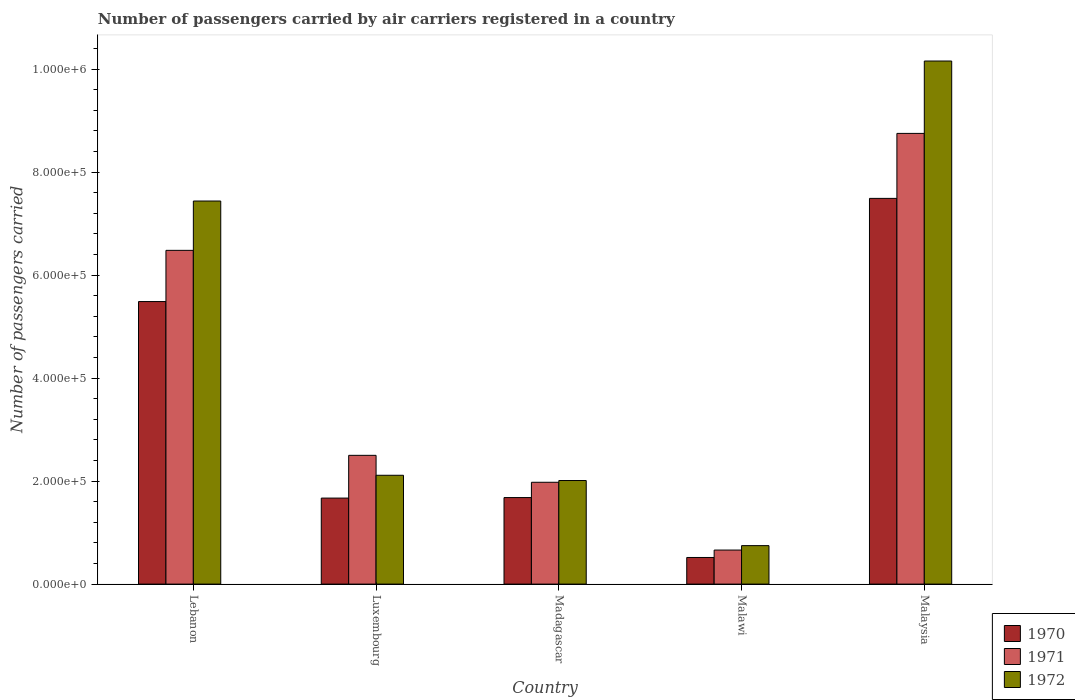How many different coloured bars are there?
Make the answer very short. 3. How many groups of bars are there?
Your answer should be very brief. 5. Are the number of bars per tick equal to the number of legend labels?
Your response must be concise. Yes. What is the label of the 3rd group of bars from the left?
Your answer should be compact. Madagascar. In how many cases, is the number of bars for a given country not equal to the number of legend labels?
Provide a short and direct response. 0. What is the number of passengers carried by air carriers in 1971 in Lebanon?
Your answer should be very brief. 6.48e+05. Across all countries, what is the maximum number of passengers carried by air carriers in 1970?
Provide a succinct answer. 7.49e+05. Across all countries, what is the minimum number of passengers carried by air carriers in 1972?
Your response must be concise. 7.47e+04. In which country was the number of passengers carried by air carriers in 1971 maximum?
Offer a very short reply. Malaysia. In which country was the number of passengers carried by air carriers in 1971 minimum?
Offer a terse response. Malawi. What is the total number of passengers carried by air carriers in 1970 in the graph?
Make the answer very short. 1.68e+06. What is the difference between the number of passengers carried by air carriers in 1970 in Luxembourg and that in Malawi?
Your answer should be very brief. 1.15e+05. What is the difference between the number of passengers carried by air carriers in 1972 in Luxembourg and the number of passengers carried by air carriers in 1971 in Lebanon?
Offer a terse response. -4.37e+05. What is the average number of passengers carried by air carriers in 1971 per country?
Your answer should be compact. 4.07e+05. What is the difference between the number of passengers carried by air carriers of/in 1970 and number of passengers carried by air carriers of/in 1972 in Lebanon?
Your response must be concise. -1.95e+05. In how many countries, is the number of passengers carried by air carriers in 1972 greater than 760000?
Offer a very short reply. 1. What is the ratio of the number of passengers carried by air carriers in 1971 in Luxembourg to that in Madagascar?
Offer a very short reply. 1.26. Is the number of passengers carried by air carriers in 1970 in Madagascar less than that in Malawi?
Provide a short and direct response. No. What is the difference between the highest and the second highest number of passengers carried by air carriers in 1972?
Make the answer very short. 2.72e+05. What is the difference between the highest and the lowest number of passengers carried by air carriers in 1970?
Your response must be concise. 6.97e+05. In how many countries, is the number of passengers carried by air carriers in 1972 greater than the average number of passengers carried by air carriers in 1972 taken over all countries?
Provide a short and direct response. 2. Is it the case that in every country, the sum of the number of passengers carried by air carriers in 1971 and number of passengers carried by air carriers in 1972 is greater than the number of passengers carried by air carriers in 1970?
Offer a very short reply. Yes. How many bars are there?
Your response must be concise. 15. How many countries are there in the graph?
Give a very brief answer. 5. What is the difference between two consecutive major ticks on the Y-axis?
Keep it short and to the point. 2.00e+05. Does the graph contain any zero values?
Give a very brief answer. No. Does the graph contain grids?
Offer a very short reply. No. Where does the legend appear in the graph?
Provide a succinct answer. Bottom right. How many legend labels are there?
Offer a very short reply. 3. What is the title of the graph?
Give a very brief answer. Number of passengers carried by air carriers registered in a country. What is the label or title of the Y-axis?
Ensure brevity in your answer.  Number of passengers carried. What is the Number of passengers carried in 1970 in Lebanon?
Ensure brevity in your answer.  5.49e+05. What is the Number of passengers carried of 1971 in Lebanon?
Your answer should be very brief. 6.48e+05. What is the Number of passengers carried of 1972 in Lebanon?
Your answer should be very brief. 7.44e+05. What is the Number of passengers carried in 1970 in Luxembourg?
Offer a very short reply. 1.67e+05. What is the Number of passengers carried in 1971 in Luxembourg?
Keep it short and to the point. 2.50e+05. What is the Number of passengers carried in 1972 in Luxembourg?
Give a very brief answer. 2.11e+05. What is the Number of passengers carried of 1970 in Madagascar?
Your response must be concise. 1.68e+05. What is the Number of passengers carried of 1971 in Madagascar?
Ensure brevity in your answer.  1.98e+05. What is the Number of passengers carried in 1972 in Madagascar?
Provide a short and direct response. 2.01e+05. What is the Number of passengers carried in 1970 in Malawi?
Provide a succinct answer. 5.17e+04. What is the Number of passengers carried in 1971 in Malawi?
Make the answer very short. 6.61e+04. What is the Number of passengers carried in 1972 in Malawi?
Make the answer very short. 7.47e+04. What is the Number of passengers carried in 1970 in Malaysia?
Keep it short and to the point. 7.49e+05. What is the Number of passengers carried of 1971 in Malaysia?
Ensure brevity in your answer.  8.75e+05. What is the Number of passengers carried of 1972 in Malaysia?
Provide a succinct answer. 1.02e+06. Across all countries, what is the maximum Number of passengers carried of 1970?
Provide a short and direct response. 7.49e+05. Across all countries, what is the maximum Number of passengers carried of 1971?
Your response must be concise. 8.75e+05. Across all countries, what is the maximum Number of passengers carried in 1972?
Ensure brevity in your answer.  1.02e+06. Across all countries, what is the minimum Number of passengers carried in 1970?
Ensure brevity in your answer.  5.17e+04. Across all countries, what is the minimum Number of passengers carried in 1971?
Your response must be concise. 6.61e+04. Across all countries, what is the minimum Number of passengers carried in 1972?
Ensure brevity in your answer.  7.47e+04. What is the total Number of passengers carried in 1970 in the graph?
Provide a short and direct response. 1.68e+06. What is the total Number of passengers carried of 1971 in the graph?
Your answer should be compact. 2.04e+06. What is the total Number of passengers carried of 1972 in the graph?
Offer a terse response. 2.25e+06. What is the difference between the Number of passengers carried of 1970 in Lebanon and that in Luxembourg?
Offer a terse response. 3.82e+05. What is the difference between the Number of passengers carried in 1971 in Lebanon and that in Luxembourg?
Your answer should be very brief. 3.98e+05. What is the difference between the Number of passengers carried of 1972 in Lebanon and that in Luxembourg?
Provide a short and direct response. 5.32e+05. What is the difference between the Number of passengers carried of 1970 in Lebanon and that in Madagascar?
Your response must be concise. 3.81e+05. What is the difference between the Number of passengers carried in 1971 in Lebanon and that in Madagascar?
Ensure brevity in your answer.  4.50e+05. What is the difference between the Number of passengers carried of 1972 in Lebanon and that in Madagascar?
Make the answer very short. 5.43e+05. What is the difference between the Number of passengers carried in 1970 in Lebanon and that in Malawi?
Offer a very short reply. 4.97e+05. What is the difference between the Number of passengers carried of 1971 in Lebanon and that in Malawi?
Provide a short and direct response. 5.82e+05. What is the difference between the Number of passengers carried of 1972 in Lebanon and that in Malawi?
Your answer should be compact. 6.69e+05. What is the difference between the Number of passengers carried in 1970 in Lebanon and that in Malaysia?
Your answer should be very brief. -2.00e+05. What is the difference between the Number of passengers carried in 1971 in Lebanon and that in Malaysia?
Provide a short and direct response. -2.27e+05. What is the difference between the Number of passengers carried of 1972 in Lebanon and that in Malaysia?
Provide a short and direct response. -2.72e+05. What is the difference between the Number of passengers carried of 1970 in Luxembourg and that in Madagascar?
Keep it short and to the point. -1000. What is the difference between the Number of passengers carried in 1971 in Luxembourg and that in Madagascar?
Offer a very short reply. 5.23e+04. What is the difference between the Number of passengers carried of 1972 in Luxembourg and that in Madagascar?
Give a very brief answer. 1.02e+04. What is the difference between the Number of passengers carried of 1970 in Luxembourg and that in Malawi?
Give a very brief answer. 1.15e+05. What is the difference between the Number of passengers carried in 1971 in Luxembourg and that in Malawi?
Make the answer very short. 1.84e+05. What is the difference between the Number of passengers carried of 1972 in Luxembourg and that in Malawi?
Offer a very short reply. 1.37e+05. What is the difference between the Number of passengers carried in 1970 in Luxembourg and that in Malaysia?
Your answer should be very brief. -5.82e+05. What is the difference between the Number of passengers carried of 1971 in Luxembourg and that in Malaysia?
Your answer should be compact. -6.25e+05. What is the difference between the Number of passengers carried of 1972 in Luxembourg and that in Malaysia?
Provide a short and direct response. -8.04e+05. What is the difference between the Number of passengers carried of 1970 in Madagascar and that in Malawi?
Your response must be concise. 1.16e+05. What is the difference between the Number of passengers carried of 1971 in Madagascar and that in Malawi?
Provide a short and direct response. 1.32e+05. What is the difference between the Number of passengers carried in 1972 in Madagascar and that in Malawi?
Your answer should be compact. 1.26e+05. What is the difference between the Number of passengers carried in 1970 in Madagascar and that in Malaysia?
Give a very brief answer. -5.81e+05. What is the difference between the Number of passengers carried of 1971 in Madagascar and that in Malaysia?
Provide a succinct answer. -6.77e+05. What is the difference between the Number of passengers carried in 1972 in Madagascar and that in Malaysia?
Provide a succinct answer. -8.14e+05. What is the difference between the Number of passengers carried of 1970 in Malawi and that in Malaysia?
Your response must be concise. -6.97e+05. What is the difference between the Number of passengers carried in 1971 in Malawi and that in Malaysia?
Offer a very short reply. -8.09e+05. What is the difference between the Number of passengers carried in 1972 in Malawi and that in Malaysia?
Give a very brief answer. -9.41e+05. What is the difference between the Number of passengers carried in 1970 in Lebanon and the Number of passengers carried in 1971 in Luxembourg?
Keep it short and to the point. 2.99e+05. What is the difference between the Number of passengers carried of 1970 in Lebanon and the Number of passengers carried of 1972 in Luxembourg?
Make the answer very short. 3.37e+05. What is the difference between the Number of passengers carried in 1971 in Lebanon and the Number of passengers carried in 1972 in Luxembourg?
Make the answer very short. 4.37e+05. What is the difference between the Number of passengers carried of 1970 in Lebanon and the Number of passengers carried of 1971 in Madagascar?
Offer a terse response. 3.51e+05. What is the difference between the Number of passengers carried in 1970 in Lebanon and the Number of passengers carried in 1972 in Madagascar?
Ensure brevity in your answer.  3.48e+05. What is the difference between the Number of passengers carried of 1971 in Lebanon and the Number of passengers carried of 1972 in Madagascar?
Give a very brief answer. 4.47e+05. What is the difference between the Number of passengers carried in 1970 in Lebanon and the Number of passengers carried in 1971 in Malawi?
Give a very brief answer. 4.82e+05. What is the difference between the Number of passengers carried in 1970 in Lebanon and the Number of passengers carried in 1972 in Malawi?
Offer a terse response. 4.74e+05. What is the difference between the Number of passengers carried in 1971 in Lebanon and the Number of passengers carried in 1972 in Malawi?
Your answer should be compact. 5.73e+05. What is the difference between the Number of passengers carried in 1970 in Lebanon and the Number of passengers carried in 1971 in Malaysia?
Ensure brevity in your answer.  -3.26e+05. What is the difference between the Number of passengers carried in 1970 in Lebanon and the Number of passengers carried in 1972 in Malaysia?
Your answer should be very brief. -4.67e+05. What is the difference between the Number of passengers carried in 1971 in Lebanon and the Number of passengers carried in 1972 in Malaysia?
Provide a succinct answer. -3.68e+05. What is the difference between the Number of passengers carried of 1970 in Luxembourg and the Number of passengers carried of 1971 in Madagascar?
Your response must be concise. -3.07e+04. What is the difference between the Number of passengers carried in 1970 in Luxembourg and the Number of passengers carried in 1972 in Madagascar?
Offer a very short reply. -3.41e+04. What is the difference between the Number of passengers carried in 1971 in Luxembourg and the Number of passengers carried in 1972 in Madagascar?
Ensure brevity in your answer.  4.89e+04. What is the difference between the Number of passengers carried in 1970 in Luxembourg and the Number of passengers carried in 1971 in Malawi?
Your answer should be very brief. 1.01e+05. What is the difference between the Number of passengers carried of 1970 in Luxembourg and the Number of passengers carried of 1972 in Malawi?
Your answer should be very brief. 9.23e+04. What is the difference between the Number of passengers carried in 1971 in Luxembourg and the Number of passengers carried in 1972 in Malawi?
Your answer should be very brief. 1.75e+05. What is the difference between the Number of passengers carried of 1970 in Luxembourg and the Number of passengers carried of 1971 in Malaysia?
Ensure brevity in your answer.  -7.08e+05. What is the difference between the Number of passengers carried in 1970 in Luxembourg and the Number of passengers carried in 1972 in Malaysia?
Provide a short and direct response. -8.49e+05. What is the difference between the Number of passengers carried in 1971 in Luxembourg and the Number of passengers carried in 1972 in Malaysia?
Keep it short and to the point. -7.66e+05. What is the difference between the Number of passengers carried in 1970 in Madagascar and the Number of passengers carried in 1971 in Malawi?
Keep it short and to the point. 1.02e+05. What is the difference between the Number of passengers carried in 1970 in Madagascar and the Number of passengers carried in 1972 in Malawi?
Provide a succinct answer. 9.33e+04. What is the difference between the Number of passengers carried in 1971 in Madagascar and the Number of passengers carried in 1972 in Malawi?
Offer a very short reply. 1.23e+05. What is the difference between the Number of passengers carried in 1970 in Madagascar and the Number of passengers carried in 1971 in Malaysia?
Offer a very short reply. -7.07e+05. What is the difference between the Number of passengers carried of 1970 in Madagascar and the Number of passengers carried of 1972 in Malaysia?
Provide a succinct answer. -8.48e+05. What is the difference between the Number of passengers carried of 1971 in Madagascar and the Number of passengers carried of 1972 in Malaysia?
Provide a short and direct response. -8.18e+05. What is the difference between the Number of passengers carried in 1970 in Malawi and the Number of passengers carried in 1971 in Malaysia?
Offer a very short reply. -8.23e+05. What is the difference between the Number of passengers carried of 1970 in Malawi and the Number of passengers carried of 1972 in Malaysia?
Provide a short and direct response. -9.64e+05. What is the difference between the Number of passengers carried of 1971 in Malawi and the Number of passengers carried of 1972 in Malaysia?
Ensure brevity in your answer.  -9.50e+05. What is the average Number of passengers carried of 1970 per country?
Offer a terse response. 3.37e+05. What is the average Number of passengers carried of 1971 per country?
Your response must be concise. 4.07e+05. What is the average Number of passengers carried of 1972 per country?
Your answer should be very brief. 4.49e+05. What is the difference between the Number of passengers carried of 1970 and Number of passengers carried of 1971 in Lebanon?
Your response must be concise. -9.94e+04. What is the difference between the Number of passengers carried in 1970 and Number of passengers carried in 1972 in Lebanon?
Your answer should be compact. -1.95e+05. What is the difference between the Number of passengers carried of 1971 and Number of passengers carried of 1972 in Lebanon?
Provide a short and direct response. -9.58e+04. What is the difference between the Number of passengers carried in 1970 and Number of passengers carried in 1971 in Luxembourg?
Ensure brevity in your answer.  -8.30e+04. What is the difference between the Number of passengers carried in 1970 and Number of passengers carried in 1972 in Luxembourg?
Your answer should be very brief. -4.43e+04. What is the difference between the Number of passengers carried in 1971 and Number of passengers carried in 1972 in Luxembourg?
Keep it short and to the point. 3.87e+04. What is the difference between the Number of passengers carried of 1970 and Number of passengers carried of 1971 in Madagascar?
Ensure brevity in your answer.  -2.97e+04. What is the difference between the Number of passengers carried in 1970 and Number of passengers carried in 1972 in Madagascar?
Provide a short and direct response. -3.31e+04. What is the difference between the Number of passengers carried of 1971 and Number of passengers carried of 1972 in Madagascar?
Offer a very short reply. -3400. What is the difference between the Number of passengers carried in 1970 and Number of passengers carried in 1971 in Malawi?
Provide a succinct answer. -1.44e+04. What is the difference between the Number of passengers carried of 1970 and Number of passengers carried of 1972 in Malawi?
Your response must be concise. -2.30e+04. What is the difference between the Number of passengers carried in 1971 and Number of passengers carried in 1972 in Malawi?
Offer a terse response. -8600. What is the difference between the Number of passengers carried in 1970 and Number of passengers carried in 1971 in Malaysia?
Your answer should be compact. -1.26e+05. What is the difference between the Number of passengers carried in 1970 and Number of passengers carried in 1972 in Malaysia?
Provide a short and direct response. -2.67e+05. What is the difference between the Number of passengers carried in 1971 and Number of passengers carried in 1972 in Malaysia?
Ensure brevity in your answer.  -1.40e+05. What is the ratio of the Number of passengers carried of 1970 in Lebanon to that in Luxembourg?
Your response must be concise. 3.29. What is the ratio of the Number of passengers carried in 1971 in Lebanon to that in Luxembourg?
Your response must be concise. 2.59. What is the ratio of the Number of passengers carried of 1972 in Lebanon to that in Luxembourg?
Your answer should be compact. 3.52. What is the ratio of the Number of passengers carried of 1970 in Lebanon to that in Madagascar?
Provide a succinct answer. 3.27. What is the ratio of the Number of passengers carried of 1971 in Lebanon to that in Madagascar?
Offer a very short reply. 3.28. What is the ratio of the Number of passengers carried of 1972 in Lebanon to that in Madagascar?
Your answer should be compact. 3.7. What is the ratio of the Number of passengers carried of 1970 in Lebanon to that in Malawi?
Make the answer very short. 10.61. What is the ratio of the Number of passengers carried in 1971 in Lebanon to that in Malawi?
Provide a succinct answer. 9.8. What is the ratio of the Number of passengers carried of 1972 in Lebanon to that in Malawi?
Offer a very short reply. 9.96. What is the ratio of the Number of passengers carried of 1970 in Lebanon to that in Malaysia?
Give a very brief answer. 0.73. What is the ratio of the Number of passengers carried in 1971 in Lebanon to that in Malaysia?
Your answer should be very brief. 0.74. What is the ratio of the Number of passengers carried of 1972 in Lebanon to that in Malaysia?
Keep it short and to the point. 0.73. What is the ratio of the Number of passengers carried of 1971 in Luxembourg to that in Madagascar?
Keep it short and to the point. 1.26. What is the ratio of the Number of passengers carried in 1972 in Luxembourg to that in Madagascar?
Give a very brief answer. 1.05. What is the ratio of the Number of passengers carried of 1970 in Luxembourg to that in Malawi?
Provide a succinct answer. 3.23. What is the ratio of the Number of passengers carried of 1971 in Luxembourg to that in Malawi?
Offer a very short reply. 3.78. What is the ratio of the Number of passengers carried of 1972 in Luxembourg to that in Malawi?
Keep it short and to the point. 2.83. What is the ratio of the Number of passengers carried in 1970 in Luxembourg to that in Malaysia?
Keep it short and to the point. 0.22. What is the ratio of the Number of passengers carried in 1971 in Luxembourg to that in Malaysia?
Offer a very short reply. 0.29. What is the ratio of the Number of passengers carried in 1972 in Luxembourg to that in Malaysia?
Your answer should be compact. 0.21. What is the ratio of the Number of passengers carried of 1970 in Madagascar to that in Malawi?
Your answer should be compact. 3.25. What is the ratio of the Number of passengers carried of 1971 in Madagascar to that in Malawi?
Your response must be concise. 2.99. What is the ratio of the Number of passengers carried in 1972 in Madagascar to that in Malawi?
Your answer should be very brief. 2.69. What is the ratio of the Number of passengers carried in 1970 in Madagascar to that in Malaysia?
Offer a very short reply. 0.22. What is the ratio of the Number of passengers carried of 1971 in Madagascar to that in Malaysia?
Ensure brevity in your answer.  0.23. What is the ratio of the Number of passengers carried of 1972 in Madagascar to that in Malaysia?
Your answer should be very brief. 0.2. What is the ratio of the Number of passengers carried of 1970 in Malawi to that in Malaysia?
Provide a short and direct response. 0.07. What is the ratio of the Number of passengers carried in 1971 in Malawi to that in Malaysia?
Your answer should be very brief. 0.08. What is the ratio of the Number of passengers carried of 1972 in Malawi to that in Malaysia?
Keep it short and to the point. 0.07. What is the difference between the highest and the second highest Number of passengers carried of 1970?
Your response must be concise. 2.00e+05. What is the difference between the highest and the second highest Number of passengers carried of 1971?
Provide a short and direct response. 2.27e+05. What is the difference between the highest and the second highest Number of passengers carried in 1972?
Make the answer very short. 2.72e+05. What is the difference between the highest and the lowest Number of passengers carried of 1970?
Ensure brevity in your answer.  6.97e+05. What is the difference between the highest and the lowest Number of passengers carried of 1971?
Your answer should be very brief. 8.09e+05. What is the difference between the highest and the lowest Number of passengers carried of 1972?
Your response must be concise. 9.41e+05. 